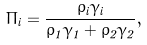Convert formula to latex. <formula><loc_0><loc_0><loc_500><loc_500>\Pi _ { i } = \frac { \rho _ { i } \gamma _ { i } } { \rho _ { 1 } \gamma _ { 1 } + \rho _ { 2 } \gamma _ { 2 } } ,</formula> 